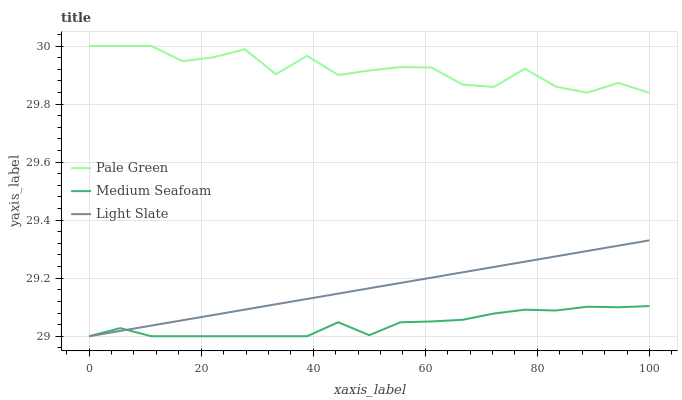Does Pale Green have the minimum area under the curve?
Answer yes or no. No. Does Medium Seafoam have the maximum area under the curve?
Answer yes or no. No. Is Medium Seafoam the smoothest?
Answer yes or no. No. Is Medium Seafoam the roughest?
Answer yes or no. No. Does Pale Green have the lowest value?
Answer yes or no. No. Does Medium Seafoam have the highest value?
Answer yes or no. No. Is Light Slate less than Pale Green?
Answer yes or no. Yes. Is Pale Green greater than Medium Seafoam?
Answer yes or no. Yes. Does Light Slate intersect Pale Green?
Answer yes or no. No. 